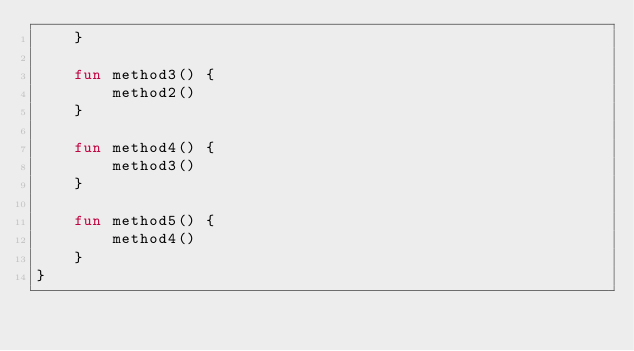Convert code to text. <code><loc_0><loc_0><loc_500><loc_500><_Kotlin_>    }

    fun method3() {
        method2()
    }

    fun method4() {
        method3()
    }

    fun method5() {
        method4()
    }
}
</code> 